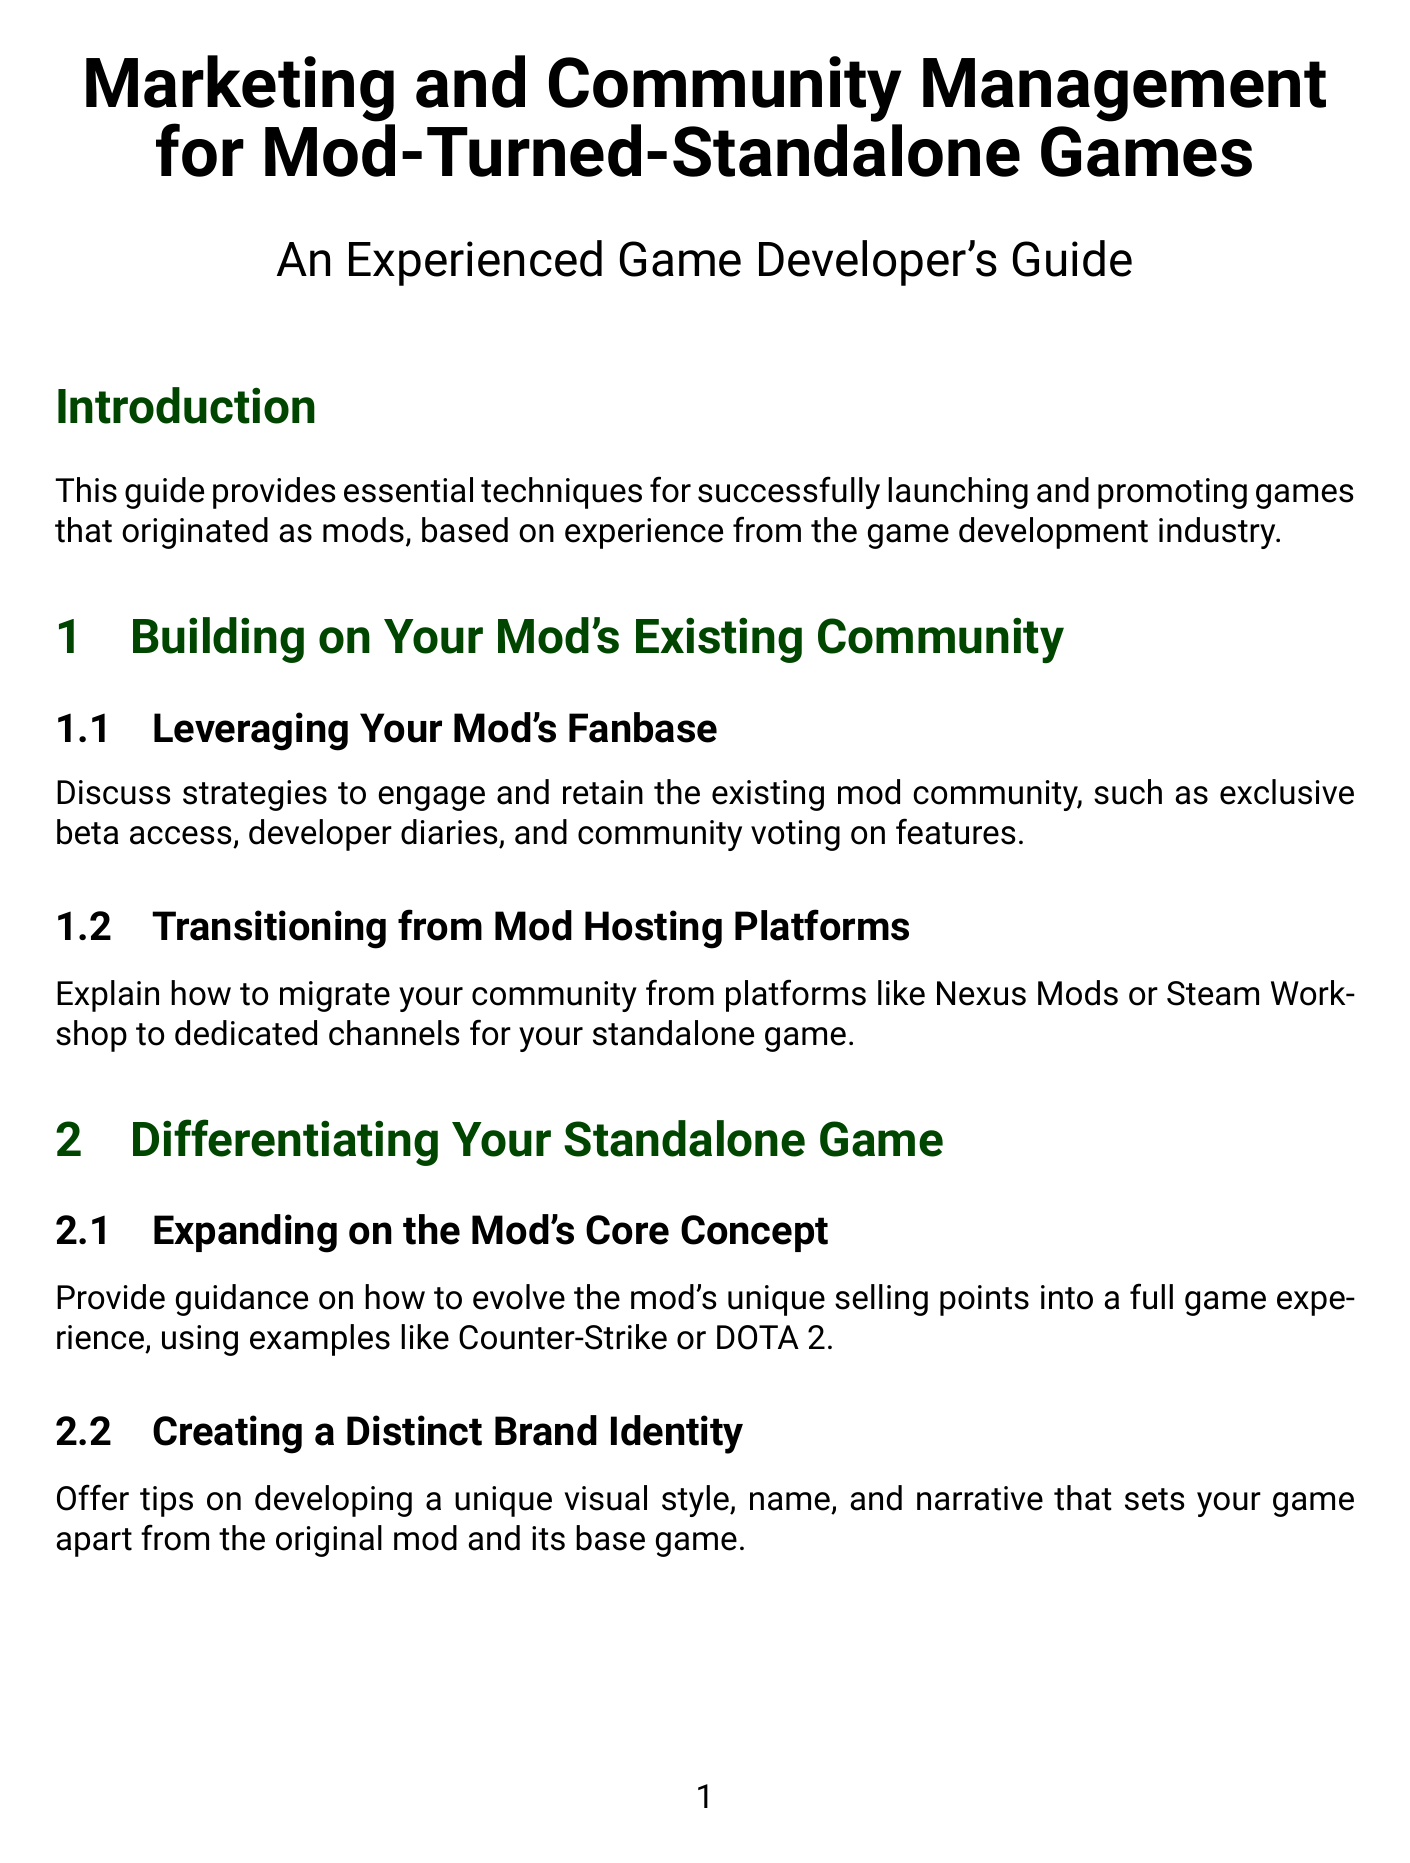What is the title of the document? The title of the document is found in the main heading at the top of the first page.
Answer: Marketing and Community Management for Mod-Turned-Standalone Games What chapter discusses managing Early Access? This can be found in the list of chapters, indicating what topics are covered in each.
Answer: Managing Early Access and Beta Testing Name one example used for evolving a mod's unique selling points. This can be found in the content under the chapter about differentiating the standalone game.
Answer: Counter-Strike Which social media platforms are recommended for community engagement? The document specifies platforms in the marketing strategies section.
Answer: Twitter, Facebook, and Discord What is one of the strategies suggested for post-launch support? The document outlines strategies in the post-launch section that helps maintain player interest.
Answer: Updates How should you approach content creators according to the guide? This is discussed under collaborating with content creators in the marketing strategies section.
Answer: Increase visibility What should be optimized on your Steam store page? This is directly articulated in the section about leveraging digital storefronts.
Answer: Store descriptions What is a suggested format for community testing? The document provides guidelines under managing early access.
Answer: Closed Beta Tests Which game is referenced for successful community interaction during Early Access? This can be found in the section discussing navigating Early Access.
Answer: Hades 